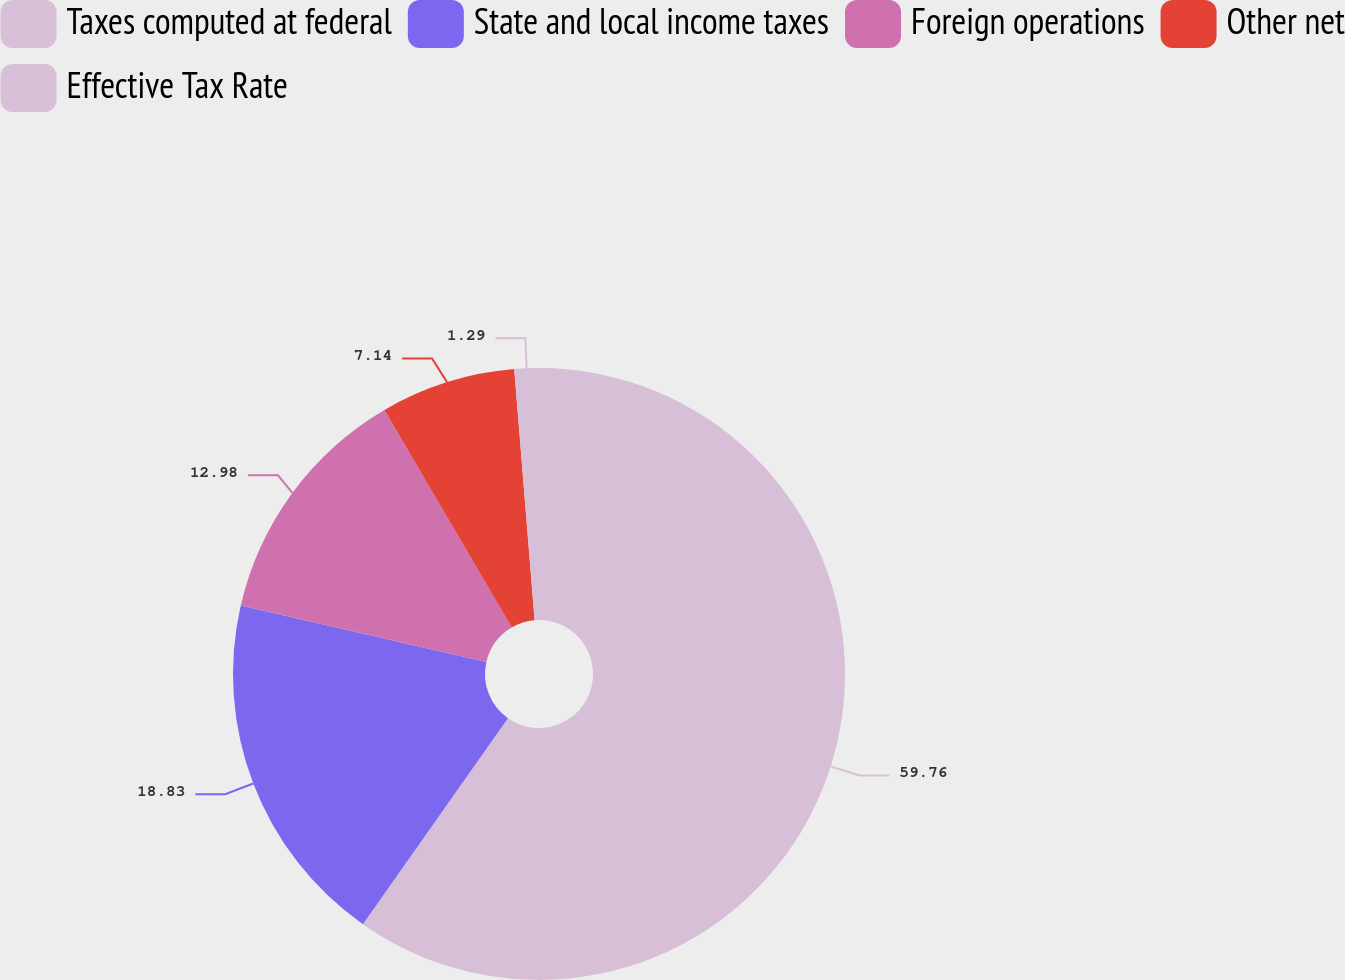Convert chart to OTSL. <chart><loc_0><loc_0><loc_500><loc_500><pie_chart><fcel>Taxes computed at federal<fcel>State and local income taxes<fcel>Foreign operations<fcel>Other net<fcel>Effective Tax Rate<nl><fcel>59.76%<fcel>18.83%<fcel>12.98%<fcel>7.14%<fcel>1.29%<nl></chart> 